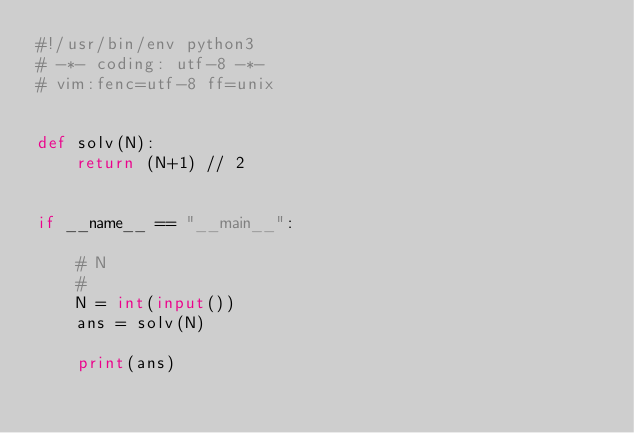<code> <loc_0><loc_0><loc_500><loc_500><_Python_>#!/usr/bin/env python3
# -*- coding: utf-8 -*-
# vim:fenc=utf-8 ff=unix


def solv(N):
    return (N+1) // 2


if __name__ == "__main__":

    # N
    #
    N = int(input())
    ans = solv(N)

    print(ans)
</code> 